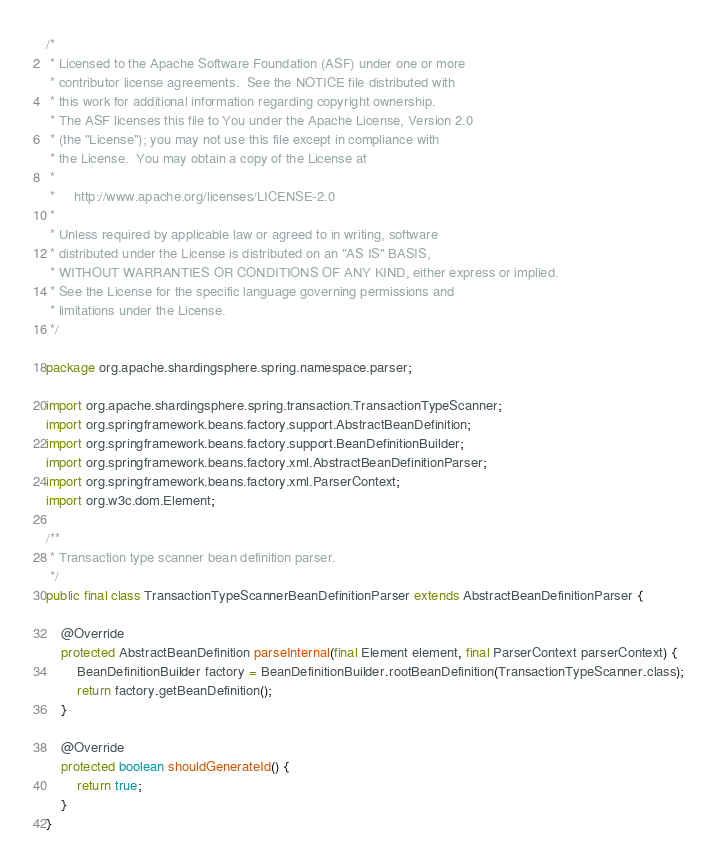<code> <loc_0><loc_0><loc_500><loc_500><_Java_>/*
 * Licensed to the Apache Software Foundation (ASF) under one or more
 * contributor license agreements.  See the NOTICE file distributed with
 * this work for additional information regarding copyright ownership.
 * The ASF licenses this file to You under the Apache License, Version 2.0
 * (the "License"); you may not use this file except in compliance with
 * the License.  You may obtain a copy of the License at
 *
 *     http://www.apache.org/licenses/LICENSE-2.0
 *
 * Unless required by applicable law or agreed to in writing, software
 * distributed under the License is distributed on an "AS IS" BASIS,
 * WITHOUT WARRANTIES OR CONDITIONS OF ANY KIND, either express or implied.
 * See the License for the specific language governing permissions and
 * limitations under the License.
 */

package org.apache.shardingsphere.spring.namespace.parser;

import org.apache.shardingsphere.spring.transaction.TransactionTypeScanner;
import org.springframework.beans.factory.support.AbstractBeanDefinition;
import org.springframework.beans.factory.support.BeanDefinitionBuilder;
import org.springframework.beans.factory.xml.AbstractBeanDefinitionParser;
import org.springframework.beans.factory.xml.ParserContext;
import org.w3c.dom.Element;

/**
 * Transaction type scanner bean definition parser.
 */
public final class TransactionTypeScannerBeanDefinitionParser extends AbstractBeanDefinitionParser {
    
    @Override
    protected AbstractBeanDefinition parseInternal(final Element element, final ParserContext parserContext) {
        BeanDefinitionBuilder factory = BeanDefinitionBuilder.rootBeanDefinition(TransactionTypeScanner.class);
        return factory.getBeanDefinition();
    }
    
    @Override
    protected boolean shouldGenerateId() {
        return true;
    }
}
</code> 